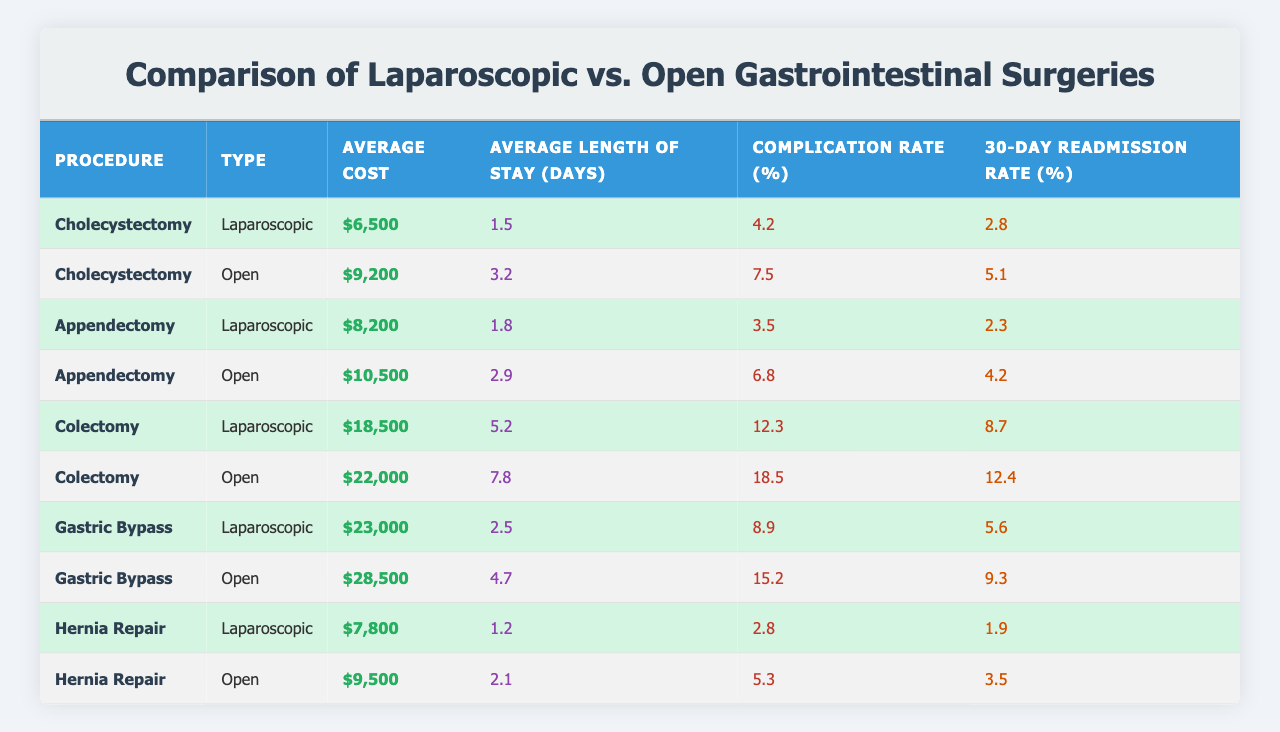What is the average cost of a laparoscopic cholecystectomy? The table shows that the average cost of a laparoscopic cholecystectomy is $6,500.
Answer: $6,500 What is the average length of stay for patients undergoing open colectomy? According to the table, the average length of stay for open colectomy is 7.8 days.
Answer: 7.8 days What is the complication rate for laparoscopic appendectomy? The complication rate for laparoscopic appendectomy, as per the table, is 3.5%.
Answer: 3.5% Which procedure has the highest 30-day readmission rate in the laparoscopic category? From the table, the laparoscopic colectomy has the highest 30-day readmission rate at 8.7%.
Answer: Laparoscopic Colectomy How much more does an open gastric bypass surgery cost compared to a laparoscopic gastric bypass surgery? The cost of open gastric bypass is $28,500, while laparoscopic gastric bypass costs $23,000. The difference is $28,500 - $23,000 = $5,500.
Answer: $5,500 True or False: The complication rate for open hernia repair is greater than that for laparoscopic hernia repair. The table indicates that the complication rate for open hernia repair is 5.3%, while for laparoscopic it is 2.8%, making the statement true.
Answer: True What is the average complication rate for laparoscopic procedures across all listed surgeries? The complication rates for laparoscopic surgeries are: 4.2% (cholecystectomy), 3.5% (appendectomy), 12.3% (colectomy), 8.9% (gastric bypass), and 2.8% (hernia repair). The average is calculated as (4.2 + 3.5 + 12.3 + 8.9 + 2.8) / 5 = 6.414%.
Answer: 6.414% If the total costs of all open procedures are summed up, what will be the result? The table lists the costs of open procedures as follows: $9,200 (cholecystectomy), $10,500 (appendectomy), $22,000 (colectomy), $28,500 (gastric bypass), and $9,500 (hernia repair). The total cost is $9,200 + $10,500 + $22,000 + $28,500 + $9,500 = $79,700.
Answer: $79,700 Which type of procedure has a lower average length of stay for each category? By comparing the average lengths of stay, for laparoscopic it's 1.5 days for cholecystectomy and 1.8 days for appendectomy, while open procedures have 3.2 days and 2.9 days respectively. Thus, laparoscopic procedures consistently have shorter lengths of stay.
Answer: Laparoscopic procedures What percentage of laparoscopic surgeries have a complication rate below 5%? The complication rates for laparoscopic surgeries are: 4.2% (cholecystectomy), 3.5% (appendectomy), 12.3% (colectomy), 8.9% (gastric bypass), and 2.8% (hernia repair). The ones below 5% are cholecystectomy, appendectomy, and hernia repair—a total of 3 out of 5, or 60%.
Answer: 60% 